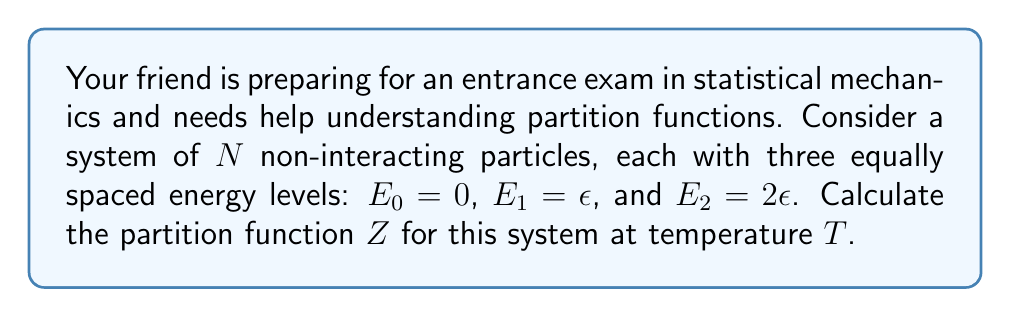What is the answer to this math problem? Let's approach this step-by-step:

1) The partition function $Z$ for a system of $N$ non-interacting particles is given by:

   $$Z = (z)^N$$

   where $z$ is the single-particle partition function.

2) For a single particle with discrete energy levels, the partition function is:

   $$z = \sum_i e^{-\beta E_i}$$

   where $\beta = \frac{1}{k_B T}$, $k_B$ is Boltzmann's constant, and $T$ is temperature.

3) In this case, we have three energy levels: $E_0 = 0$, $E_1 = \epsilon$, and $E_2 = 2\epsilon$. Let's substitute these into the single-particle partition function:

   $$z = e^{-\beta \cdot 0} + e^{-\beta \epsilon} + e^{-\beta \cdot 2\epsilon}$$

4) Simplify:

   $$z = 1 + e^{-\beta \epsilon} + e^{-2\beta \epsilon}$$

5) Now, we can write the full partition function for $N$ particles:

   $$Z = (1 + e^{-\beta \epsilon} + e^{-2\beta \epsilon})^N$$

This is the final form of the partition function for this system.
Answer: $Z = (1 + e^{-\beta \epsilon} + e^{-2\beta \epsilon})^N$ 